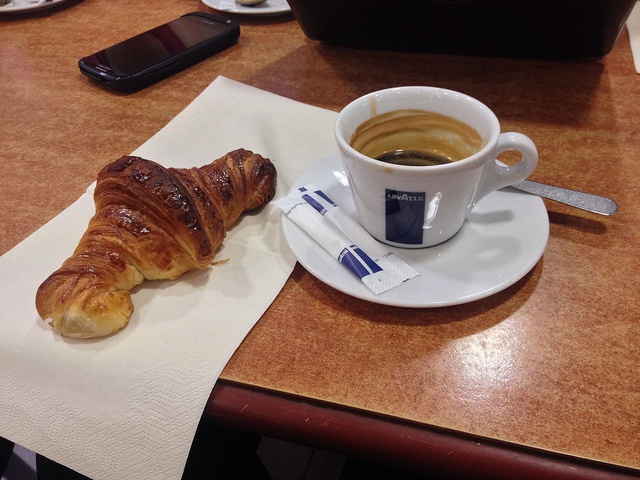Describe the objects in this image and their specific colors. I can see dining table in black, salmon, brown, and lightgray tones, cup in black, darkgray, olive, and gray tones, laptop in black, maroon, and brown tones, cell phone in black, maroon, and purple tones, and spoon in black, gray, and brown tones in this image. 